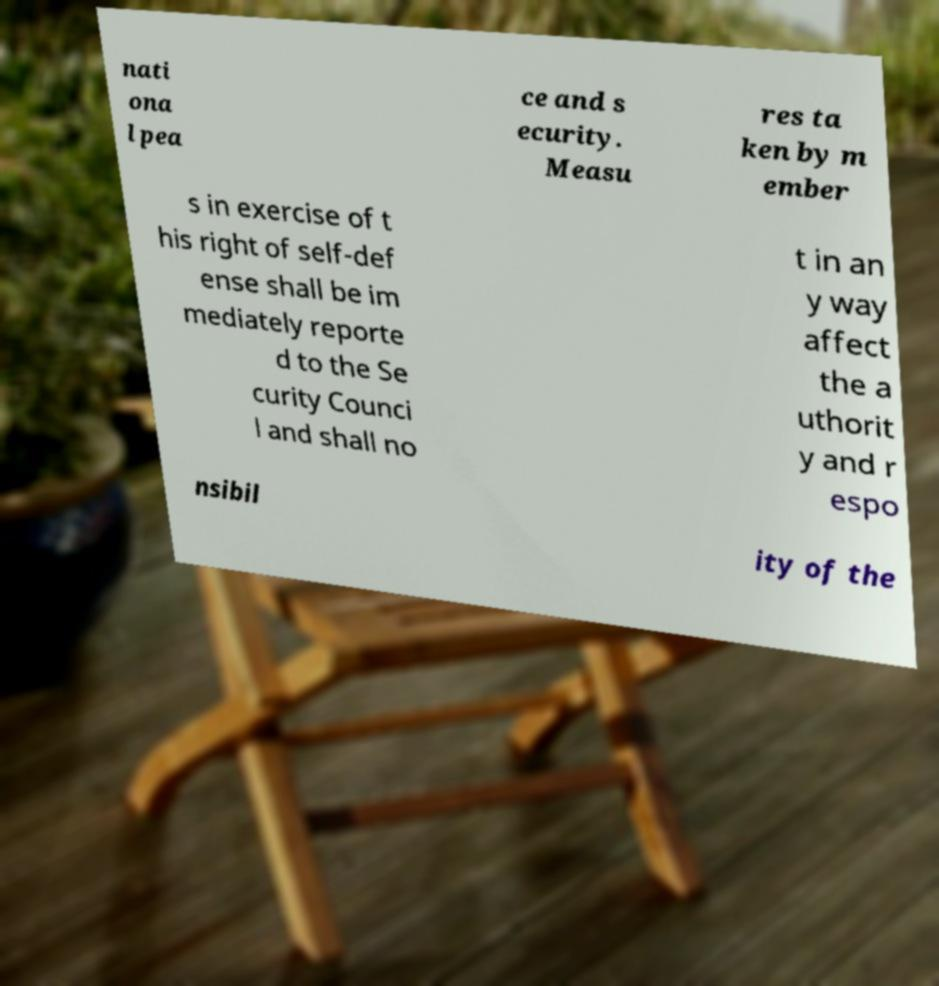Could you assist in decoding the text presented in this image and type it out clearly? nati ona l pea ce and s ecurity. Measu res ta ken by m ember s in exercise of t his right of self-def ense shall be im mediately reporte d to the Se curity Counci l and shall no t in an y way affect the a uthorit y and r espo nsibil ity of the 